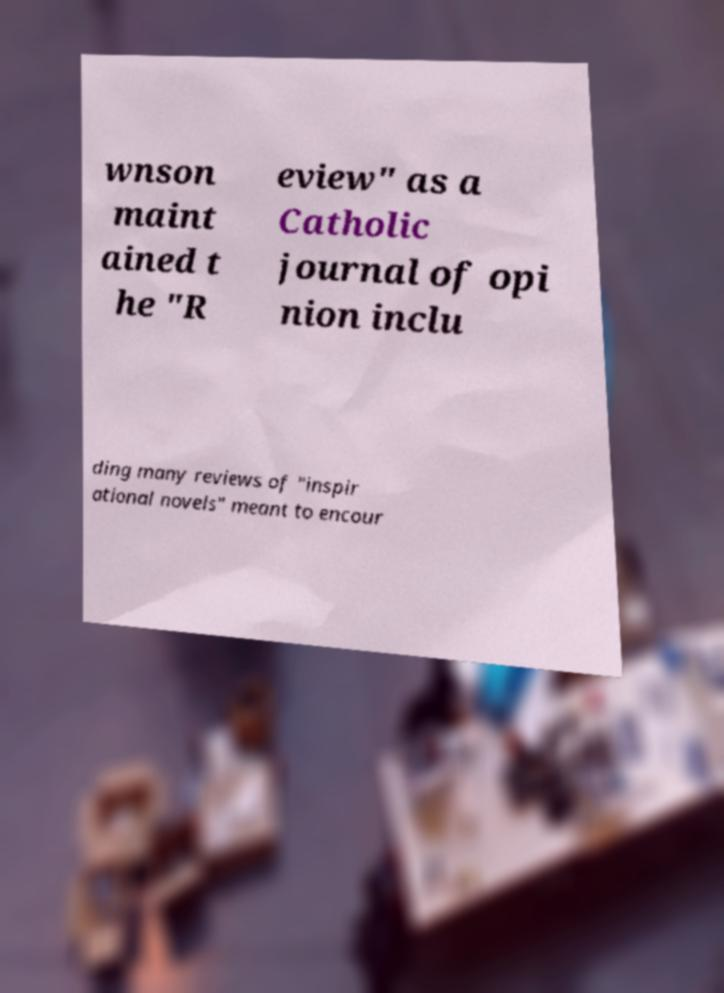Could you assist in decoding the text presented in this image and type it out clearly? wnson maint ained t he "R eview" as a Catholic journal of opi nion inclu ding many reviews of "inspir ational novels" meant to encour 